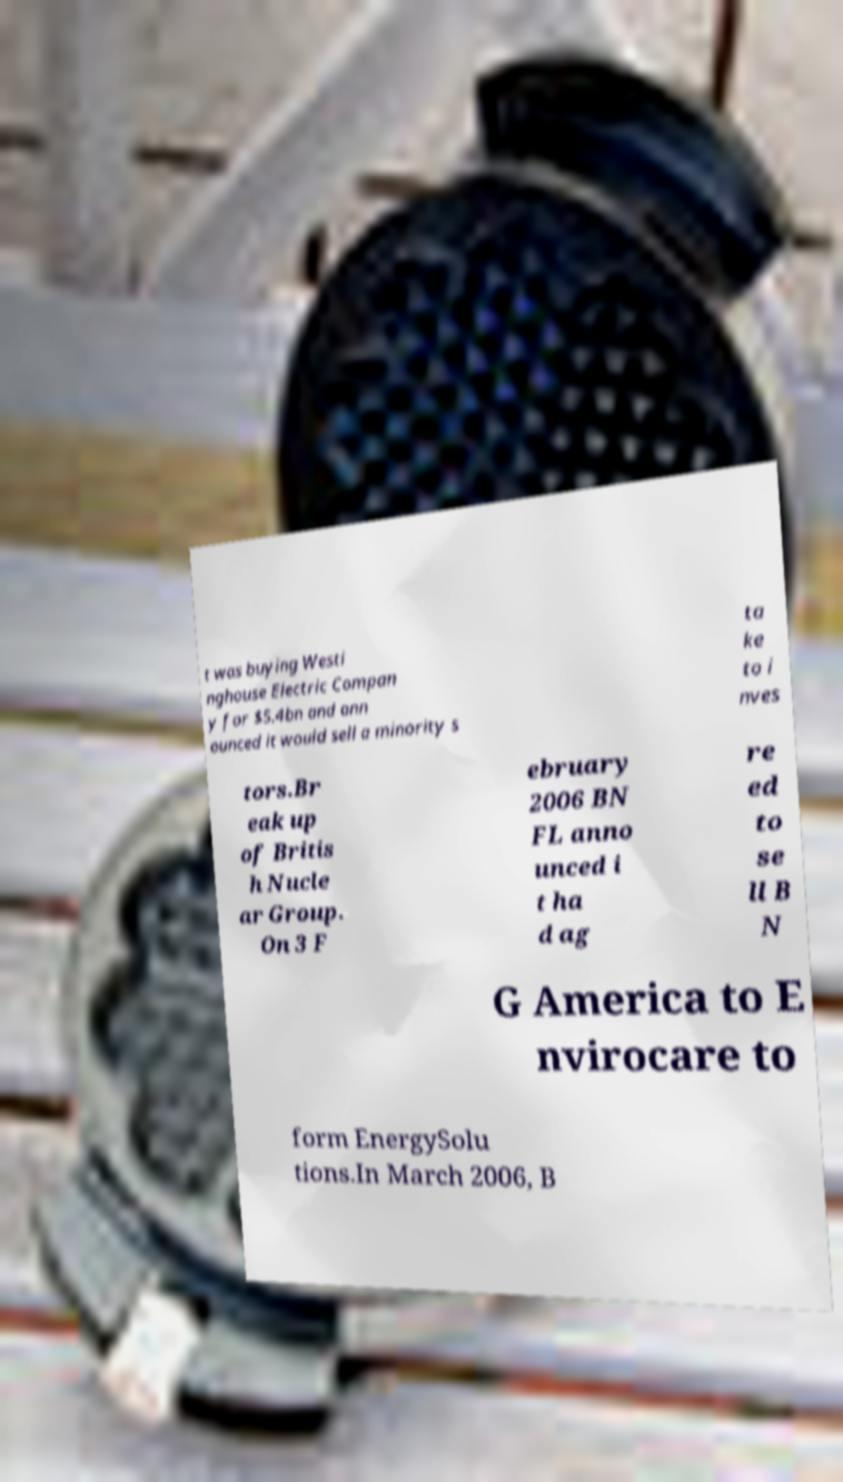Could you assist in decoding the text presented in this image and type it out clearly? t was buying Westi nghouse Electric Compan y for $5.4bn and ann ounced it would sell a minority s ta ke to i nves tors.Br eak up of Britis h Nucle ar Group. On 3 F ebruary 2006 BN FL anno unced i t ha d ag re ed to se ll B N G America to E nvirocare to form EnergySolu tions.In March 2006, B 